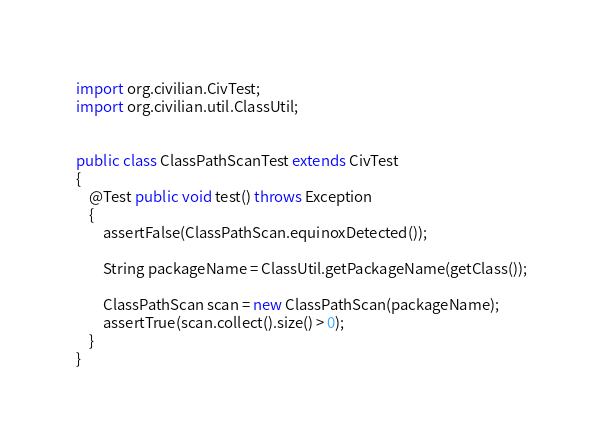<code> <loc_0><loc_0><loc_500><loc_500><_Java_>import org.civilian.CivTest;
import org.civilian.util.ClassUtil;


public class ClassPathScanTest extends CivTest
{
	@Test public void test() throws Exception
	{
		assertFalse(ClassPathScan.equinoxDetected());
		
		String packageName = ClassUtil.getPackageName(getClass());
		
		ClassPathScan scan = new ClassPathScan(packageName);
		assertTrue(scan.collect().size() > 0);
	}
}
</code> 